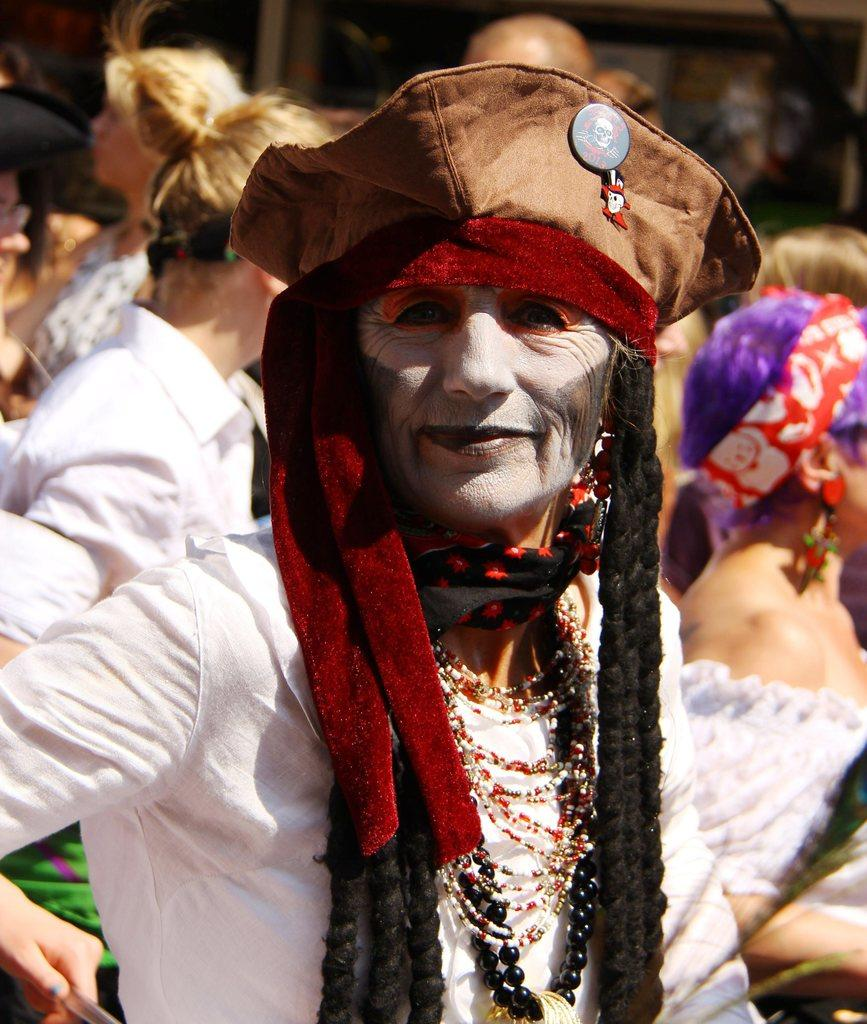How many persons are in the image? There is a group of persons in the image. What are the persons wearing in the image? The persons are wearing different costumes. What are the persons doing in the image? The persons are standing in the image. What type of bear can be seen walking among the persons in the image? There is no bear present in the image; it features a group of persons wearing different costumes and standing. 